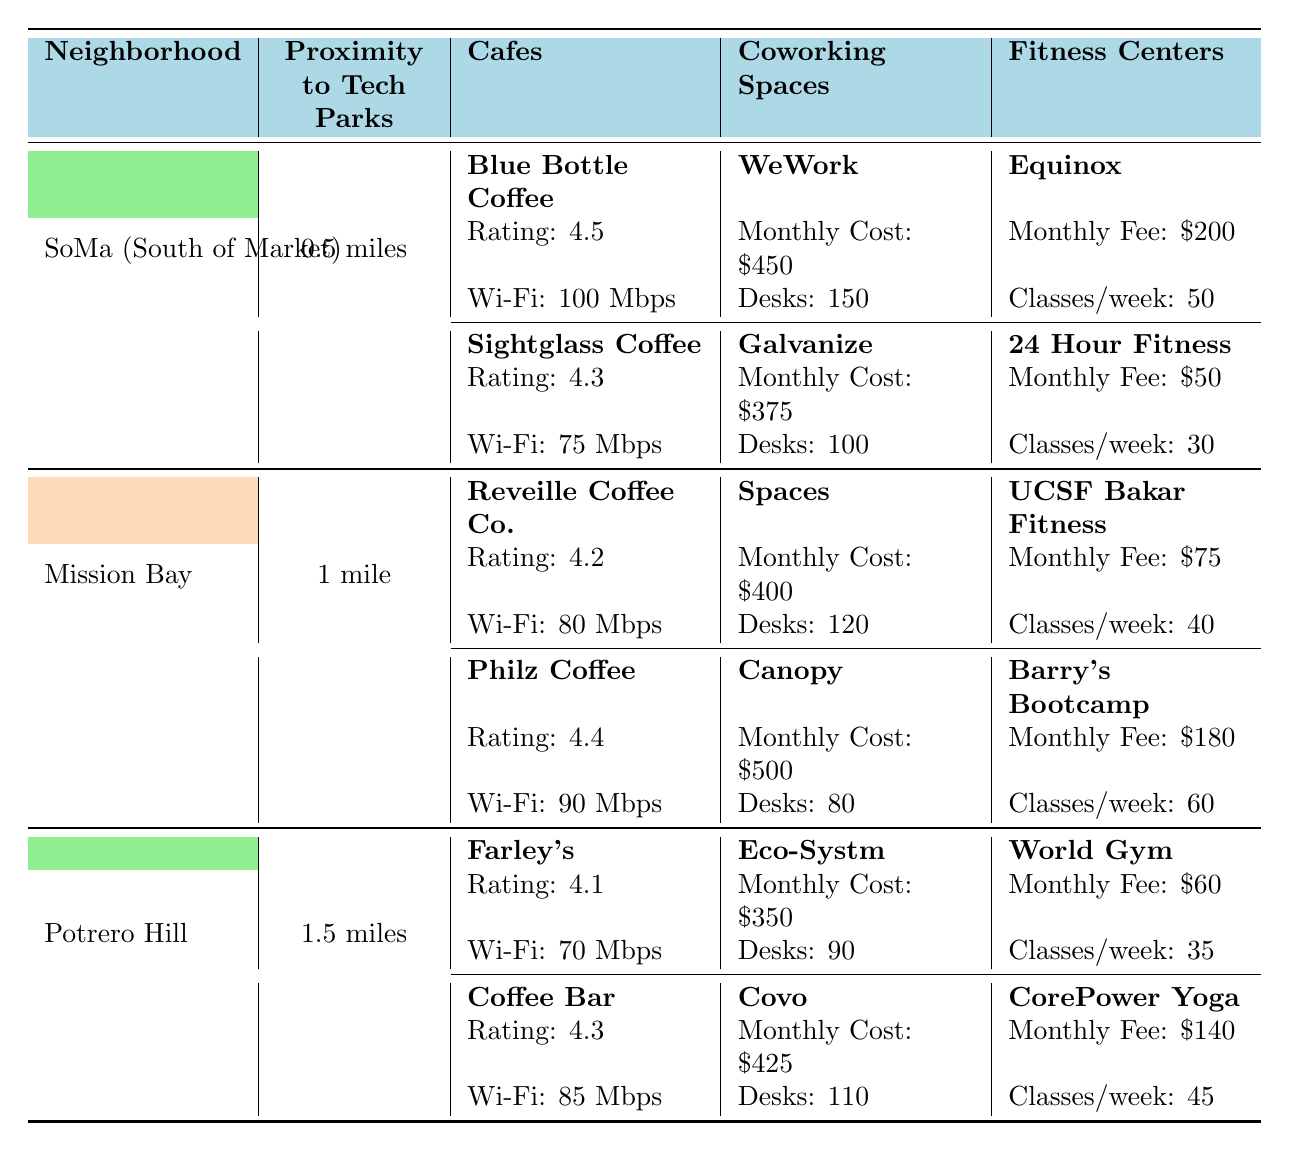What is the rating of Blue Bottle Coffee? The table lists the cafes in the SoMa neighborhood, and under Blue Bottle Coffee it shows a rating of 4.5.
Answer: 4.5 How many available desks does Spaces offer in Mission Bay? In the Mission Bay section of the table, under the coworking spaces, the entry for Spaces indicates it has 120 available desks.
Answer: 120 Which fitness center has the highest monthly fee in Potrero Hill? Looking at the monthly fees under fitness centers in Potrero Hill, Equinox has the highest fee at $200, compared to World Gym at $60 and CorePower Yoga at $140.
Answer: Equinox What is the average Wi-Fi speed of cafes in the SoMa neighborhood? The Wi-Fi speeds for cafes in SoMa are 100 Mbps and 75 Mbps. Adding these gives 175 Mbps, and dividing by 2 results in an average Wi-Fi speed of 87.5 Mbps.
Answer: 87.5 Mbps Is the rating of Philz Coffee higher than that of Reveille Coffee Co.? Philz Coffee has a rating of 4.4 and Reveille Coffee Co. has a rating of 4.2. Since 4.4 is greater than 4.2, the statement is true.
Answer: Yes How much does it cost on average to use coworking spaces in SoMa? In SoMa, the coworking spaces are WeWork at $450 and Galvanize at $375. The total cost is $450 + $375 = $825, and dividing this by 2 gives an average cost of $412.50.
Answer: $412.50 Which neighborhood has the most fitness classes per week across its fitness centers? In SoMa, the classes per week sum to 80 (50 for Equinox and 30 for 24 Hour Fitness), in Mission Bay it sums to 100 (40 for UCSF Bakar and 60 for Barry's), and in Potrero Hill it sums to 80 (35 for World Gym and 45 for CorePower). Therefore, Mission Bay has the highest sum at 100 classes per week.
Answer: Mission Bay What is the total monthly fee for fitness centers in Potrero Hill? The monthly fees in Potrero Hill are $60 for World Gym and $140 for CorePower Yoga. Summing these gives $200 as the total monthly fee.
Answer: $200 Which cafe has faster Wi-Fi, Sightglass Coffee or Coffee Bar? Sightglass Coffee has a Wi-Fi speed of 75 Mbps, while Coffee Bar has 85 Mbps. Since 85 Mbps is greater than 75 Mbps, Coffee Bar has faster Wi-Fi.
Answer: Coffee Bar How many total available desks do the coworking spaces in Mission Bay have? The available desks in Mission Bay are 120 for Spaces and 80 for Canopy. Adding these gives a total of 200 available desks across both coworking spaces.
Answer: 200 